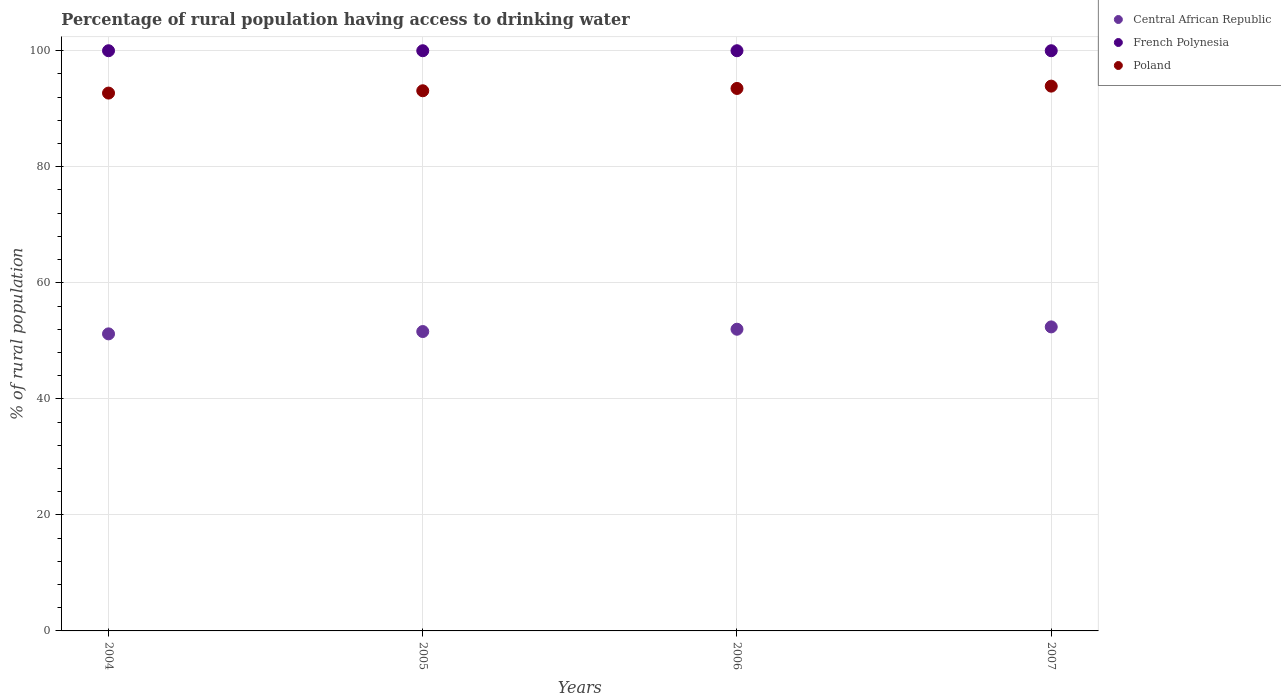How many different coloured dotlines are there?
Ensure brevity in your answer.  3. What is the percentage of rural population having access to drinking water in Central African Republic in 2004?
Offer a very short reply. 51.2. Across all years, what is the maximum percentage of rural population having access to drinking water in French Polynesia?
Give a very brief answer. 100. Across all years, what is the minimum percentage of rural population having access to drinking water in Central African Republic?
Provide a short and direct response. 51.2. In which year was the percentage of rural population having access to drinking water in French Polynesia maximum?
Keep it short and to the point. 2004. In which year was the percentage of rural population having access to drinking water in Central African Republic minimum?
Your answer should be very brief. 2004. What is the total percentage of rural population having access to drinking water in Poland in the graph?
Give a very brief answer. 373.2. What is the difference between the percentage of rural population having access to drinking water in Poland in 2006 and that in 2007?
Keep it short and to the point. -0.4. What is the difference between the percentage of rural population having access to drinking water in Central African Republic in 2004 and the percentage of rural population having access to drinking water in Poland in 2007?
Provide a succinct answer. -42.7. What is the average percentage of rural population having access to drinking water in Poland per year?
Your answer should be compact. 93.3. In the year 2005, what is the difference between the percentage of rural population having access to drinking water in Central African Republic and percentage of rural population having access to drinking water in Poland?
Provide a short and direct response. -41.5. What is the ratio of the percentage of rural population having access to drinking water in Poland in 2005 to that in 2006?
Your answer should be very brief. 1. Is the percentage of rural population having access to drinking water in French Polynesia in 2005 less than that in 2007?
Keep it short and to the point. No. Is the difference between the percentage of rural population having access to drinking water in Central African Republic in 2004 and 2007 greater than the difference between the percentage of rural population having access to drinking water in Poland in 2004 and 2007?
Provide a succinct answer. Yes. What is the difference between the highest and the second highest percentage of rural population having access to drinking water in Central African Republic?
Your answer should be very brief. 0.4. What is the difference between the highest and the lowest percentage of rural population having access to drinking water in Central African Republic?
Make the answer very short. 1.2. Is the percentage of rural population having access to drinking water in Central African Republic strictly greater than the percentage of rural population having access to drinking water in Poland over the years?
Keep it short and to the point. No. Is the percentage of rural population having access to drinking water in Poland strictly less than the percentage of rural population having access to drinking water in French Polynesia over the years?
Offer a very short reply. Yes. How many dotlines are there?
Give a very brief answer. 3. Does the graph contain grids?
Your answer should be very brief. Yes. How many legend labels are there?
Ensure brevity in your answer.  3. How are the legend labels stacked?
Provide a succinct answer. Vertical. What is the title of the graph?
Ensure brevity in your answer.  Percentage of rural population having access to drinking water. Does "West Bank and Gaza" appear as one of the legend labels in the graph?
Provide a short and direct response. No. What is the label or title of the X-axis?
Ensure brevity in your answer.  Years. What is the label or title of the Y-axis?
Provide a succinct answer. % of rural population. What is the % of rural population of Central African Republic in 2004?
Your answer should be very brief. 51.2. What is the % of rural population in French Polynesia in 2004?
Your answer should be very brief. 100. What is the % of rural population of Poland in 2004?
Offer a very short reply. 92.7. What is the % of rural population in Central African Republic in 2005?
Provide a short and direct response. 51.6. What is the % of rural population of Poland in 2005?
Ensure brevity in your answer.  93.1. What is the % of rural population in Poland in 2006?
Make the answer very short. 93.5. What is the % of rural population in Central African Republic in 2007?
Your answer should be very brief. 52.4. What is the % of rural population in Poland in 2007?
Keep it short and to the point. 93.9. Across all years, what is the maximum % of rural population of Central African Republic?
Your answer should be very brief. 52.4. Across all years, what is the maximum % of rural population in French Polynesia?
Offer a terse response. 100. Across all years, what is the maximum % of rural population in Poland?
Provide a succinct answer. 93.9. Across all years, what is the minimum % of rural population in Central African Republic?
Ensure brevity in your answer.  51.2. Across all years, what is the minimum % of rural population of Poland?
Offer a very short reply. 92.7. What is the total % of rural population in Central African Republic in the graph?
Make the answer very short. 207.2. What is the total % of rural population in Poland in the graph?
Provide a short and direct response. 373.2. What is the difference between the % of rural population of Central African Republic in 2004 and that in 2005?
Keep it short and to the point. -0.4. What is the difference between the % of rural population of French Polynesia in 2004 and that in 2005?
Your answer should be very brief. 0. What is the difference between the % of rural population in Central African Republic in 2004 and that in 2006?
Offer a very short reply. -0.8. What is the difference between the % of rural population of Poland in 2004 and that in 2006?
Your response must be concise. -0.8. What is the difference between the % of rural population of Central African Republic in 2004 and that in 2007?
Keep it short and to the point. -1.2. What is the difference between the % of rural population of French Polynesia in 2004 and that in 2007?
Offer a very short reply. 0. What is the difference between the % of rural population in Poland in 2004 and that in 2007?
Keep it short and to the point. -1.2. What is the difference between the % of rural population of French Polynesia in 2005 and that in 2006?
Give a very brief answer. 0. What is the difference between the % of rural population in Poland in 2005 and that in 2006?
Provide a succinct answer. -0.4. What is the difference between the % of rural population in Central African Republic in 2005 and that in 2007?
Ensure brevity in your answer.  -0.8. What is the difference between the % of rural population of French Polynesia in 2006 and that in 2007?
Ensure brevity in your answer.  0. What is the difference between the % of rural population of Central African Republic in 2004 and the % of rural population of French Polynesia in 2005?
Offer a terse response. -48.8. What is the difference between the % of rural population in Central African Republic in 2004 and the % of rural population in Poland in 2005?
Provide a succinct answer. -41.9. What is the difference between the % of rural population of Central African Republic in 2004 and the % of rural population of French Polynesia in 2006?
Your response must be concise. -48.8. What is the difference between the % of rural population in Central African Republic in 2004 and the % of rural population in Poland in 2006?
Make the answer very short. -42.3. What is the difference between the % of rural population of French Polynesia in 2004 and the % of rural population of Poland in 2006?
Provide a succinct answer. 6.5. What is the difference between the % of rural population in Central African Republic in 2004 and the % of rural population in French Polynesia in 2007?
Offer a very short reply. -48.8. What is the difference between the % of rural population in Central African Republic in 2004 and the % of rural population in Poland in 2007?
Your answer should be very brief. -42.7. What is the difference between the % of rural population of French Polynesia in 2004 and the % of rural population of Poland in 2007?
Offer a terse response. 6.1. What is the difference between the % of rural population in Central African Republic in 2005 and the % of rural population in French Polynesia in 2006?
Your response must be concise. -48.4. What is the difference between the % of rural population of Central African Republic in 2005 and the % of rural population of Poland in 2006?
Your answer should be very brief. -41.9. What is the difference between the % of rural population of Central African Republic in 2005 and the % of rural population of French Polynesia in 2007?
Provide a short and direct response. -48.4. What is the difference between the % of rural population in Central African Republic in 2005 and the % of rural population in Poland in 2007?
Offer a very short reply. -42.3. What is the difference between the % of rural population of French Polynesia in 2005 and the % of rural population of Poland in 2007?
Ensure brevity in your answer.  6.1. What is the difference between the % of rural population of Central African Republic in 2006 and the % of rural population of French Polynesia in 2007?
Your answer should be very brief. -48. What is the difference between the % of rural population of Central African Republic in 2006 and the % of rural population of Poland in 2007?
Provide a short and direct response. -41.9. What is the average % of rural population of Central African Republic per year?
Your response must be concise. 51.8. What is the average % of rural population in French Polynesia per year?
Provide a short and direct response. 100. What is the average % of rural population of Poland per year?
Your answer should be compact. 93.3. In the year 2004, what is the difference between the % of rural population in Central African Republic and % of rural population in French Polynesia?
Your response must be concise. -48.8. In the year 2004, what is the difference between the % of rural population of Central African Republic and % of rural population of Poland?
Keep it short and to the point. -41.5. In the year 2004, what is the difference between the % of rural population of French Polynesia and % of rural population of Poland?
Your response must be concise. 7.3. In the year 2005, what is the difference between the % of rural population of Central African Republic and % of rural population of French Polynesia?
Your response must be concise. -48.4. In the year 2005, what is the difference between the % of rural population of Central African Republic and % of rural population of Poland?
Give a very brief answer. -41.5. In the year 2005, what is the difference between the % of rural population of French Polynesia and % of rural population of Poland?
Offer a terse response. 6.9. In the year 2006, what is the difference between the % of rural population in Central African Republic and % of rural population in French Polynesia?
Your answer should be compact. -48. In the year 2006, what is the difference between the % of rural population in Central African Republic and % of rural population in Poland?
Ensure brevity in your answer.  -41.5. In the year 2007, what is the difference between the % of rural population of Central African Republic and % of rural population of French Polynesia?
Provide a succinct answer. -47.6. In the year 2007, what is the difference between the % of rural population in Central African Republic and % of rural population in Poland?
Your answer should be very brief. -41.5. In the year 2007, what is the difference between the % of rural population of French Polynesia and % of rural population of Poland?
Offer a very short reply. 6.1. What is the ratio of the % of rural population in Central African Republic in 2004 to that in 2005?
Provide a succinct answer. 0.99. What is the ratio of the % of rural population in Central African Republic in 2004 to that in 2006?
Ensure brevity in your answer.  0.98. What is the ratio of the % of rural population of French Polynesia in 2004 to that in 2006?
Provide a succinct answer. 1. What is the ratio of the % of rural population in Poland in 2004 to that in 2006?
Your answer should be very brief. 0.99. What is the ratio of the % of rural population in Central African Republic in 2004 to that in 2007?
Provide a succinct answer. 0.98. What is the ratio of the % of rural population in French Polynesia in 2004 to that in 2007?
Your answer should be very brief. 1. What is the ratio of the % of rural population of Poland in 2004 to that in 2007?
Offer a terse response. 0.99. What is the ratio of the % of rural population in French Polynesia in 2005 to that in 2006?
Make the answer very short. 1. What is the ratio of the % of rural population in Central African Republic in 2005 to that in 2007?
Provide a succinct answer. 0.98. What is the ratio of the % of rural population in Poland in 2005 to that in 2007?
Ensure brevity in your answer.  0.99. What is the ratio of the % of rural population in Central African Republic in 2006 to that in 2007?
Keep it short and to the point. 0.99. What is the difference between the highest and the second highest % of rural population of French Polynesia?
Your response must be concise. 0. What is the difference between the highest and the lowest % of rural population in Central African Republic?
Offer a terse response. 1.2. What is the difference between the highest and the lowest % of rural population of Poland?
Ensure brevity in your answer.  1.2. 